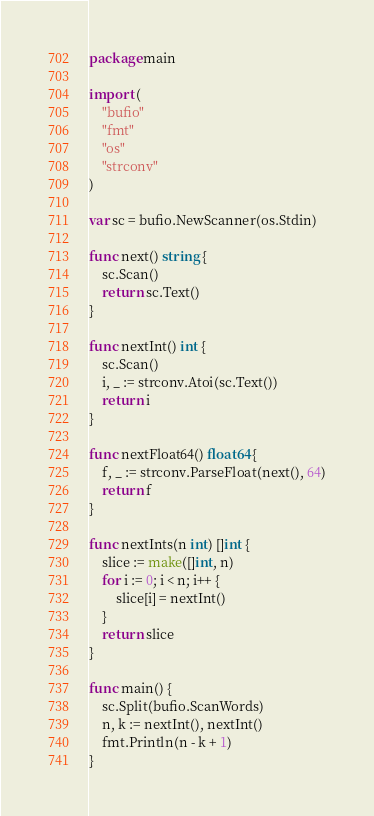<code> <loc_0><loc_0><loc_500><loc_500><_Go_>package main

import (
	"bufio"
	"fmt"
	"os"
	"strconv"
)

var sc = bufio.NewScanner(os.Stdin)

func next() string {
	sc.Scan()
	return sc.Text()
}

func nextInt() int {
	sc.Scan()
	i, _ := strconv.Atoi(sc.Text())
	return i
}

func nextFloat64() float64 {
	f, _ := strconv.ParseFloat(next(), 64)
	return f
}

func nextInts(n int) []int {
	slice := make([]int, n)
	for i := 0; i < n; i++ {
		slice[i] = nextInt()
	}
	return slice
}

func main() {
	sc.Split(bufio.ScanWords)
	n, k := nextInt(), nextInt()
	fmt.Println(n - k + 1)
}
</code> 